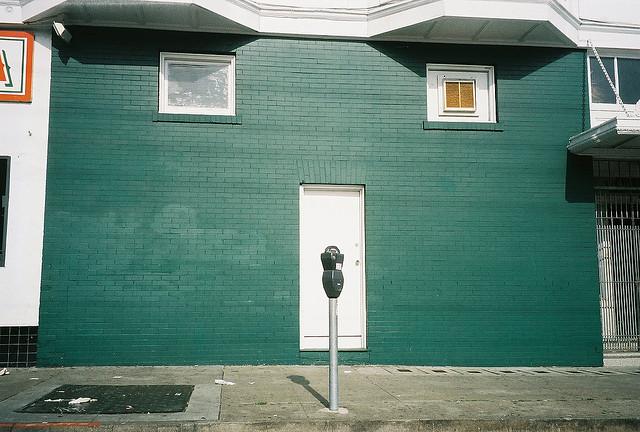What color is the door?
Answer briefly. White. What does the meter keep track of?
Be succinct. Parking time. How many treetops are visible?
Concise answer only. 0. What is behind the meter?
Keep it brief. Door. What object is this?
Be succinct. Parking meter. 